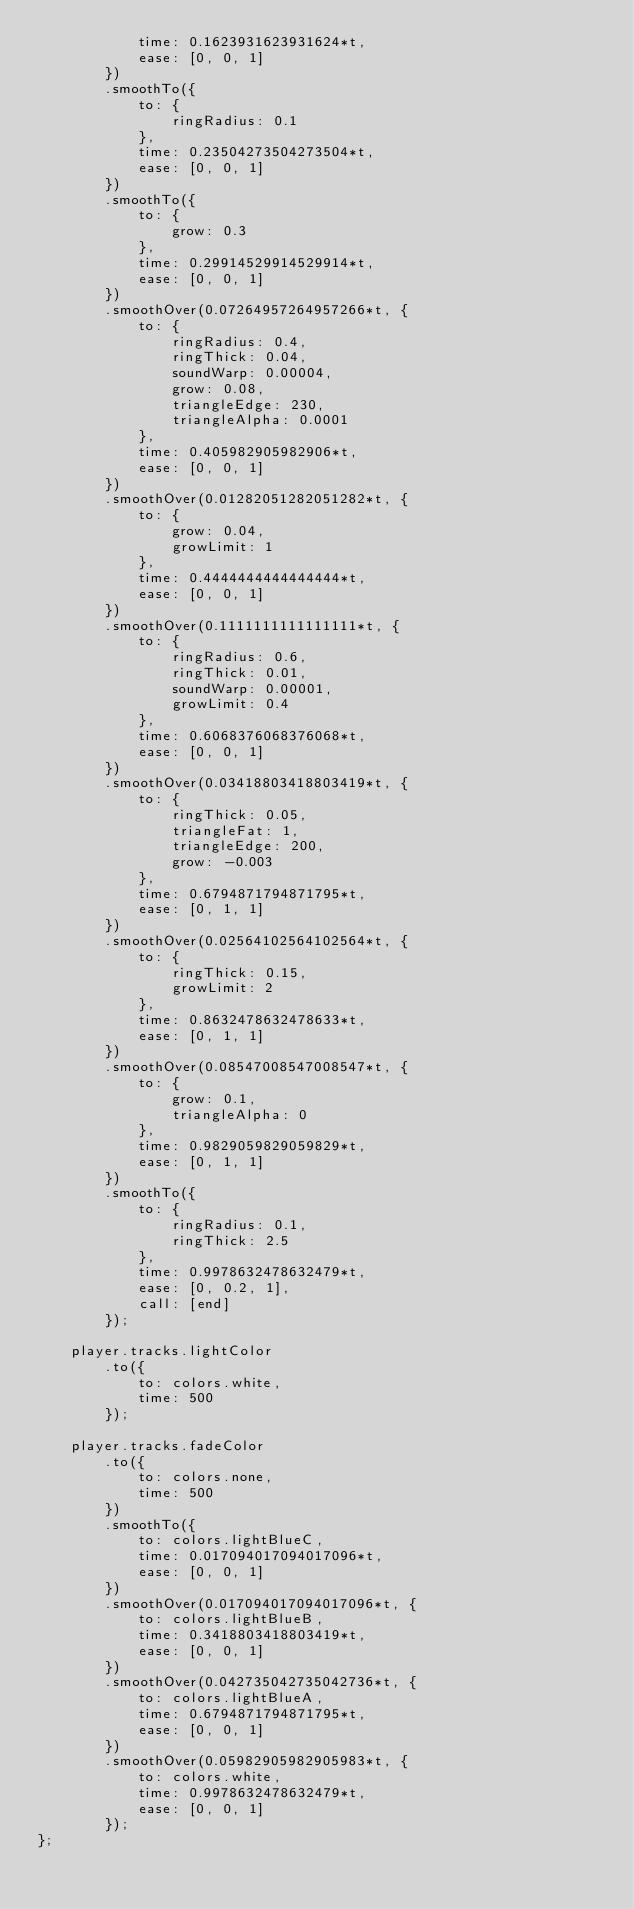Convert code to text. <code><loc_0><loc_0><loc_500><loc_500><_JavaScript_>            time: 0.1623931623931624*t,
            ease: [0, 0, 1]
        })
        .smoothTo({
            to: {
                ringRadius: 0.1
            },
            time: 0.23504273504273504*t,
            ease: [0, 0, 1]
        })
        .smoothTo({
            to: {
                grow: 0.3
            },
            time: 0.29914529914529914*t,
            ease: [0, 0, 1]
        })
        .smoothOver(0.07264957264957266*t, {
            to: {
                ringRadius: 0.4,
                ringThick: 0.04,
                soundWarp: 0.00004,
                grow: 0.08,
                triangleEdge: 230,
                triangleAlpha: 0.0001
            },
            time: 0.405982905982906*t,
            ease: [0, 0, 1]
        })
        .smoothOver(0.01282051282051282*t, {
            to: {
                grow: 0.04,
                growLimit: 1
            },
            time: 0.4444444444444444*t,
            ease: [0, 0, 1]
        })
        .smoothOver(0.1111111111111111*t, {
            to: {
                ringRadius: 0.6,
                ringThick: 0.01,
                soundWarp: 0.00001,
                growLimit: 0.4
            },
            time: 0.6068376068376068*t,
            ease: [0, 0, 1]
        })
        .smoothOver(0.03418803418803419*t, {
            to: {
                ringThick: 0.05,
                triangleFat: 1,
                triangleEdge: 200,
                grow: -0.003
            },
            time: 0.6794871794871795*t,
            ease: [0, 1, 1]
        })
        .smoothOver(0.02564102564102564*t, {
            to: {
                ringThick: 0.15,
                growLimit: 2
            },
            time: 0.8632478632478633*t,
            ease: [0, 1, 1]
        })
        .smoothOver(0.08547008547008547*t, {
            to: {
                grow: 0.1,
                triangleAlpha: 0
            },
            time: 0.9829059829059829*t,
            ease: [0, 1, 1]
        })
        .smoothTo({
            to: {
                ringRadius: 0.1,
                ringThick: 2.5
            },
            time: 0.9978632478632479*t,
            ease: [0, 0.2, 1],
            call: [end]
        });

    player.tracks.lightColor
        .to({
            to: colors.white,
            time: 500
        });

    player.tracks.fadeColor
        .to({
            to: colors.none,
            time: 500
        })
        .smoothTo({
            to: colors.lightBlueC,
            time: 0.017094017094017096*t,
            ease: [0, 0, 1]
        })
        .smoothOver(0.017094017094017096*t, {
            to: colors.lightBlueB,
            time: 0.3418803418803419*t,
            ease: [0, 0, 1]
        })
        .smoothOver(0.042735042735042736*t, {
            to: colors.lightBlueA,
            time: 0.6794871794871795*t,
            ease: [0, 0, 1]
        })
        .smoothOver(0.05982905982905983*t, {
            to: colors.white,
            time: 0.9978632478632479*t,
            ease: [0, 0, 1]
        });
};</code> 